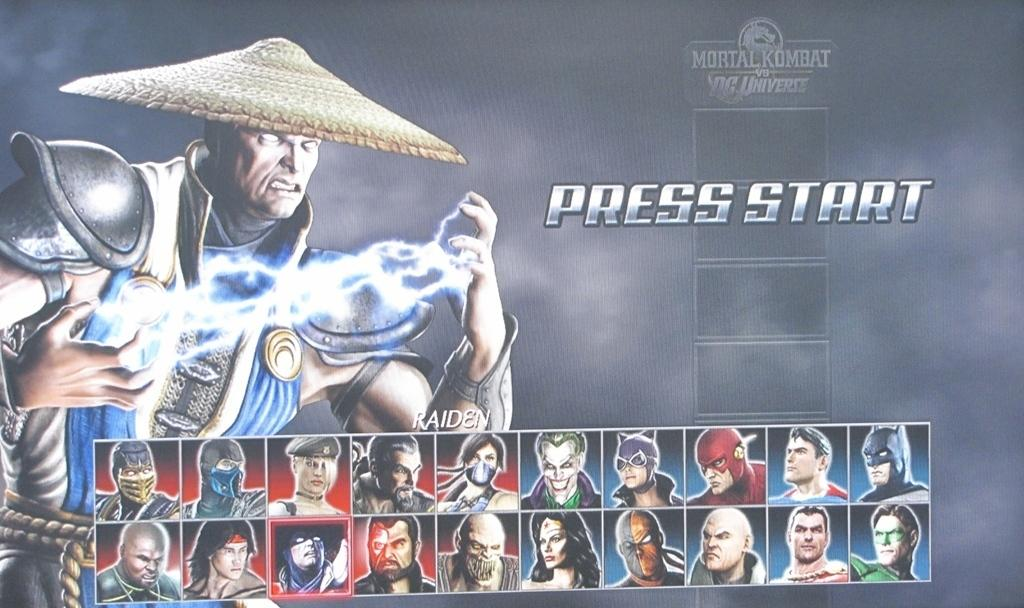What is the main image on the poster? There is an image of a man with thunder in between his hands on the poster. What else can be seen at the bottom of the poster? There are there any other images? Is there any text on the poster? Yes, there is text on the poster. How many bikes are parked in the alley shown on the poster? There is no alley or bikes present on the poster; it features an image of a man with thunder in between his hands and images of people at the bottom. 